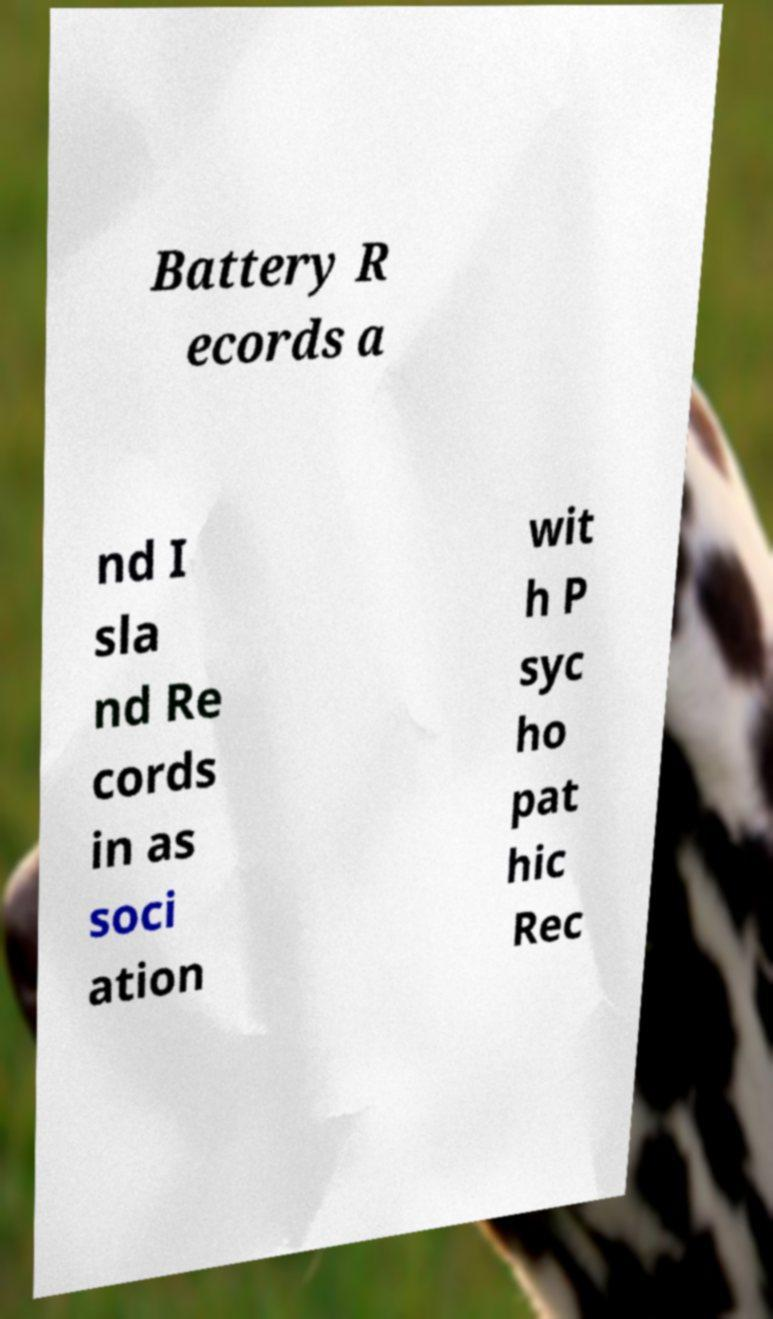I need the written content from this picture converted into text. Can you do that? Battery R ecords a nd I sla nd Re cords in as soci ation wit h P syc ho pat hic Rec 